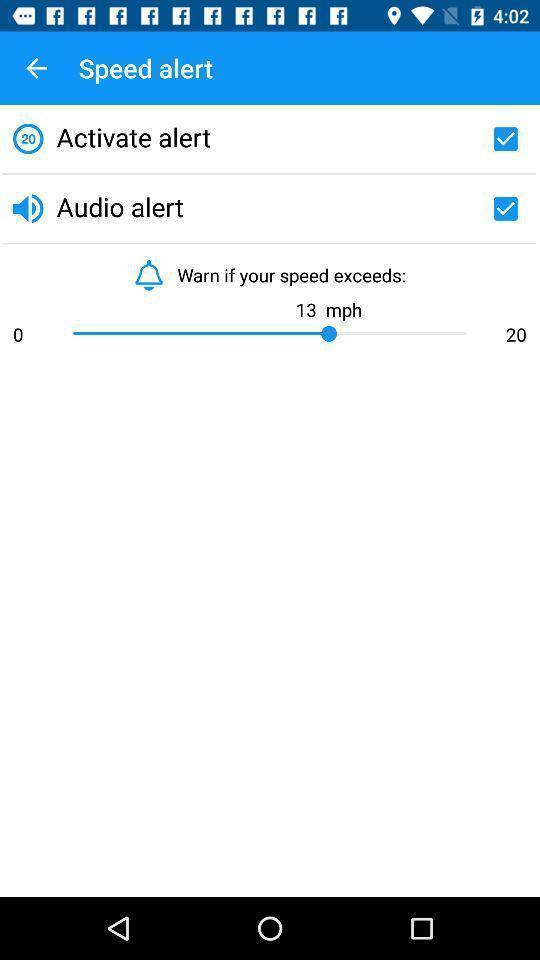Provide a detailed account of this screenshot. Page showing multiple alert check boxes with speed limit. 